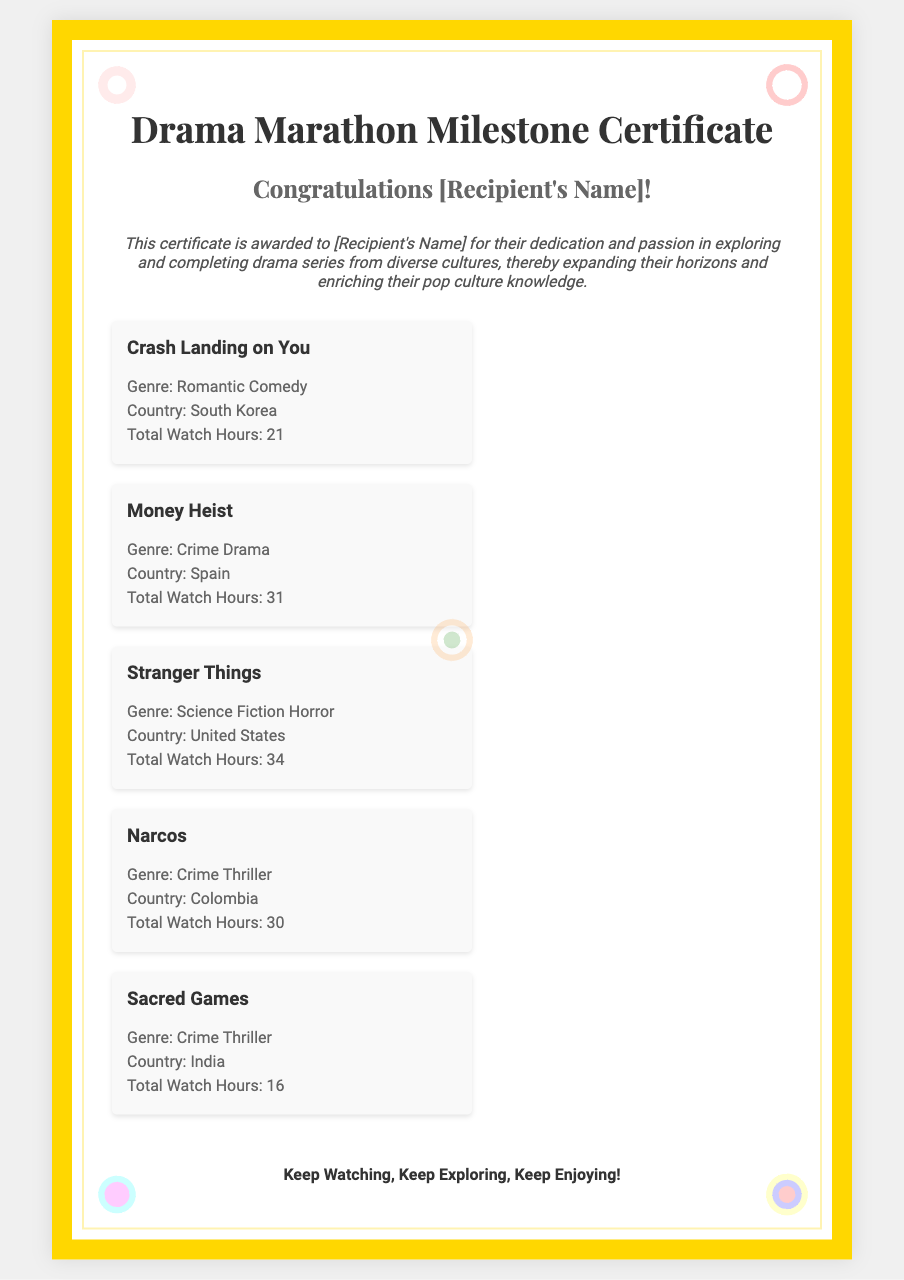What is the title of the first drama listed? The first drama listed in the document is "Crash Landing on You."
Answer: Crash Landing on You How many total watch hours does "Money Heist" have? The document states that "Money Heist" has a total of 31 watch hours.
Answer: 31 Which country is "Sacred Games" from? The document indicates that "Sacred Games" is from India.
Answer: India What genre is "Stranger Things"? According to the document, "Stranger Things" falls under the genre of Science Fiction Horror.
Answer: Science Fiction Horror How many drama series are featured on the certificate? The document lists a total of five drama series.
Answer: Five What is the theme of the certificate? The theme relates to celebrating dedication in exploring and completing drama series from diverse cultures.
Answer: Diversity in drama series Who is the recipient of this certificate? The document mentions "[Recipient's Name]" but does not specify a name.
Answer: [Recipient's Name] What is the total watch hours for "Narcos"? The document specifies that "Narcos" has a total of 30 watch hours.
Answer: 30 Which genre does "Crash Landing on You" belong to? The document categorizes "Crash Landing on You" as a Romantic Comedy.
Answer: Romantic Comedy 